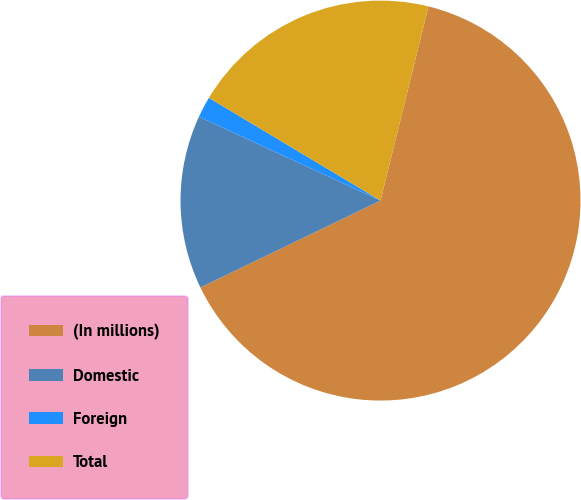Convert chart to OTSL. <chart><loc_0><loc_0><loc_500><loc_500><pie_chart><fcel>(In millions)<fcel>Domestic<fcel>Foreign<fcel>Total<nl><fcel>63.99%<fcel>14.04%<fcel>1.7%<fcel>20.27%<nl></chart> 